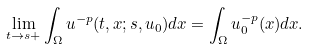<formula> <loc_0><loc_0><loc_500><loc_500>\lim _ { t \to s + } \int _ { \Omega } u ^ { - p } ( t , x ; s , u _ { 0 } ) d x = \int _ { \Omega } u ^ { - p } _ { 0 } ( x ) d x .</formula> 